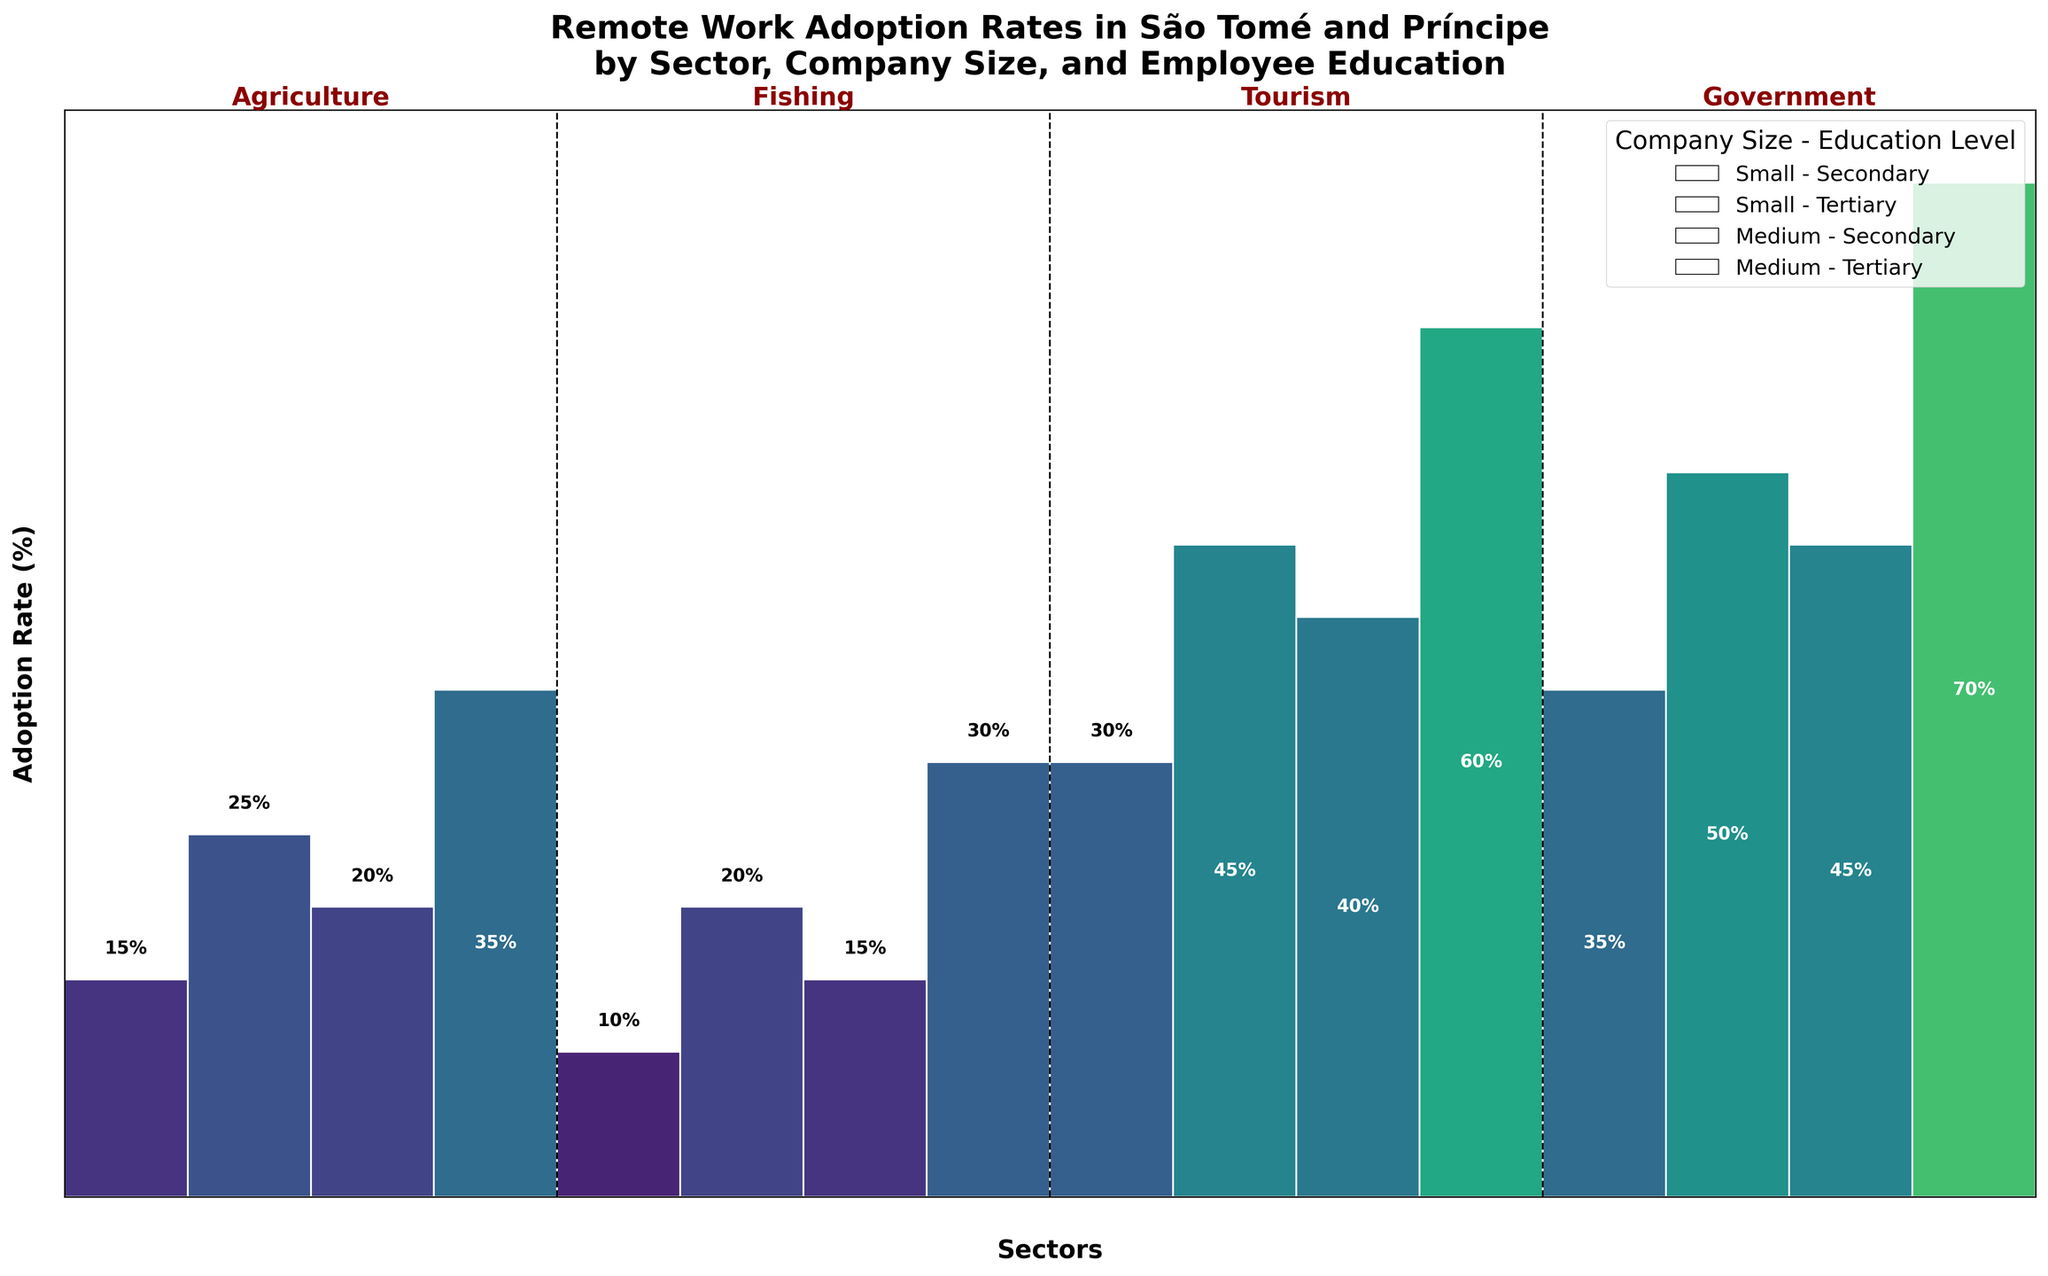What is the title of the plot? The title of the plot is written at the top and reads: "Remote Work Adoption Rates in São Tomé and Príncipe by Sector, Company Size, and Employee Education".
Answer: Remote Work Adoption Rates in São Tomé and Príncipe by Sector, Company Size, and Employee Education Which sector has the highest remote work adoption rate for medium-sized companies with tertiary-educated employees? The highest adoption rate for medium-sized companies with tertiary-educated employees is represented by the tallest rectangle in the medium column that is colored according to the adoption rate, which is highest in the Government sector.
Answer: Government What is the difference in adoption rates for small companies with tertiary education between the Agriculture and Tourism sectors? Compare the height of the rectangles for small companies with tertiary education in both Agriculture and Tourism sectors. In Agriculture, it is 25%, and in Tourism, it is 45%. Calculating the difference: 45 - 25 = 20.
Answer: 20% Which sector has the lowest remote work adoption rate for small companies with secondary-educated employees? The lowest adoption rate for small companies with secondary-educated employees is the shortest rectangle in the small column with secondary education, which is in the Fishing sector at 10%.
Answer: Fishing What is the combined remote work adoption rate for medium companies with secondary-educated employees in the Agriculture and Fishing sectors? Find the adoption rates for medium companies with secondary education in Agriculture and Fishing sectors from their respective rectangles. Agriculture has 20% and Fishing has 15%. Adding these together, 20 + 15 = 35.
Answer: 35% Which sectors show an adoption rate greater than 50% for any of the education and company size categories? Identify any rectangles that extend beyond the 50% mark. The Government sector shows adoption rates greater than 50% for medium companies with tertiary education, and the Tourism sector for medium companies with tertiary education.
Answer: Government, Tourism 